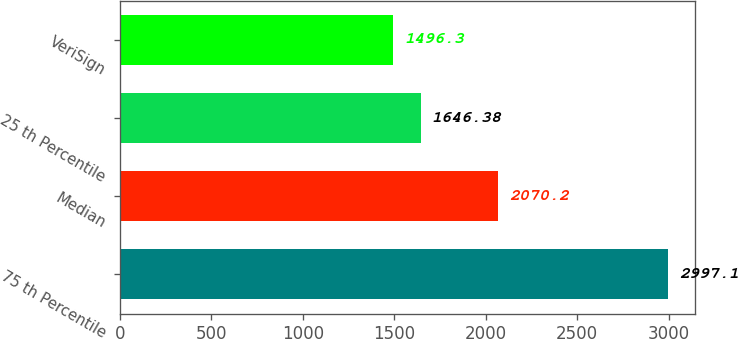<chart> <loc_0><loc_0><loc_500><loc_500><bar_chart><fcel>75 th Percentile<fcel>Median<fcel>25 th Percentile<fcel>VeriSign<nl><fcel>2997.1<fcel>2070.2<fcel>1646.38<fcel>1496.3<nl></chart> 